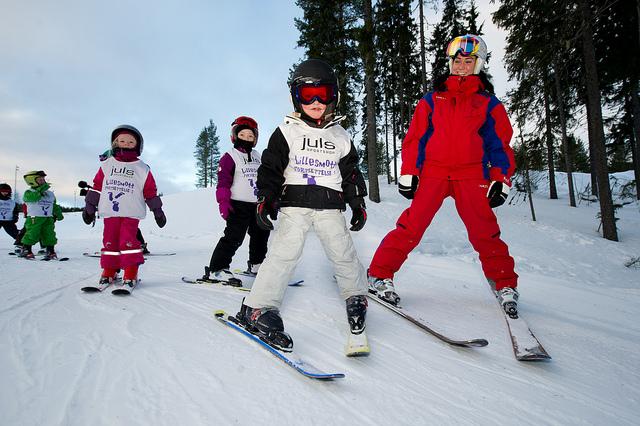What are the kids doing?
Give a very brief answer. Skiing. How many people have pants and coat that are the same color?
Be succinct. 2. How many people are in the picture?
Concise answer only. 6. If someone pushes one of these children, which direction would they slide?
Write a very short answer. Down. How many people are smiling?
Keep it brief. 1. Are they going uphill or downhill?
Be succinct. Downhill. What color is the adult's outfit?
Keep it brief. Red. 